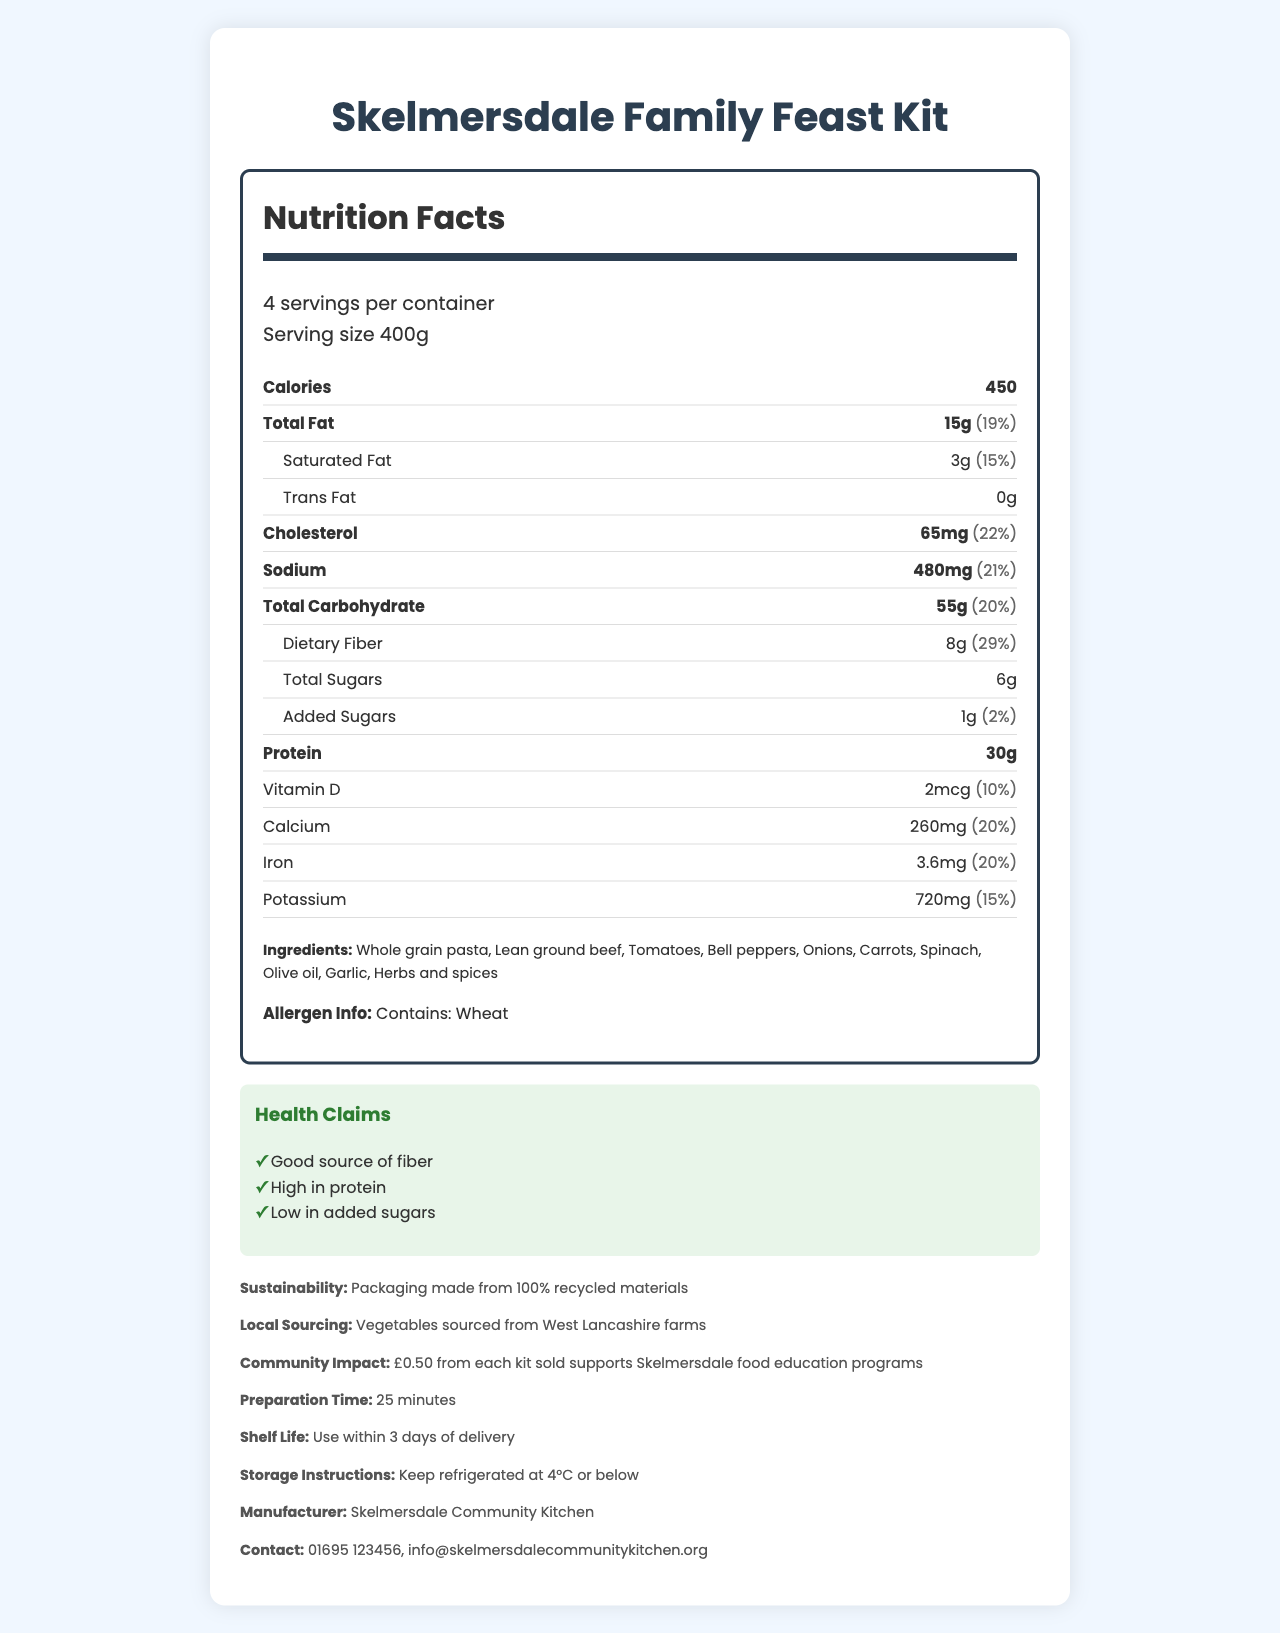What is the serving size of the Skelmersdale Family Feast Kit? Serving size is mentioned at the top of the Nutrition Facts section.
Answer: 400g How many servings are there per container? The number of servings per container is mentioned at the top of the Nutrition Facts section.
Answer: 4 What is the amount of total fat per serving? The amount of total fat is listed in the Nutrition Facts section.
Answer: 15g How much dietary fiber does each serving provide? The dietary fiber per serving is listed under the Total Carbohydrate section in the Nutrition Facts.
Answer: 8g What percentage of the daily value of sodium is in one serving? The daily value percentage for sodium is listed in the Nutrition Facts section.
Answer: 21% How many grams of protein are in one serving? The protein content per serving is provided in the Nutrition Facts section.
Answer: 30g What are some of the main ingredients in the meal kit? The ingredient list is provided in the document.
Answer: Whole grain pasta, Lean ground beef, Tomatoes, Bell peppers, Onions, Carrots, Spinach, Olive oil, Garlic, Herbs and spices What health claims are made about the Skelmersdale Family Feast Kit? The health claims section lists these attributes.
Answer: Good source of fiber, High in protein, Low in added sugars Which statement is true about the ingredients? A. Contains nuts B. Contains dairy C. Contains wheat The allergen information clearly states "Contains: Wheat".
Answer: C What is the daily value percentage for iron per serving? A. 15% B. 20% C. 25% D. 30% The daily value percentage for iron is listed as 20% in the Nutrition Facts section.
Answer: B Is the packaging of the Skelmersdale Family Feast Kit sustainable? The sustainability information states that the packaging is made from 100% recycled materials.
Answer: Yes Does the document mention that the vegetables are sourced locally? The local sourcing information confirms that the vegetables are sourced from West Lancashire farms.
Answer: Yes Can we determine the price of the Skelmersdale Family Feast Kit from this document? The document does not include any details about the pricing.
Answer: Not enough information What is the main focus of the Nutrition Facts Label for the Skelmersdale Family Feast Kit? The document includes nutritional values, ingredient lists, health claims, local sourcing, sustainability, and community impact information, all aimed at promoting healthy and responsible eating choices.
Answer: The label provides detailed nutritional information, ingredients, health claims, and additional information to support healthy eating habits for families in Skelmersdale. 